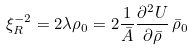Convert formula to latex. <formula><loc_0><loc_0><loc_500><loc_500>\xi _ { R } ^ { - 2 } = 2 \lambda \rho _ { 0 } = 2 \frac { 1 } { \bar { A } } \frac { \partial ^ { 2 } U } { \partial \bar { \rho } } \, \bar { \rho } _ { 0 }</formula> 